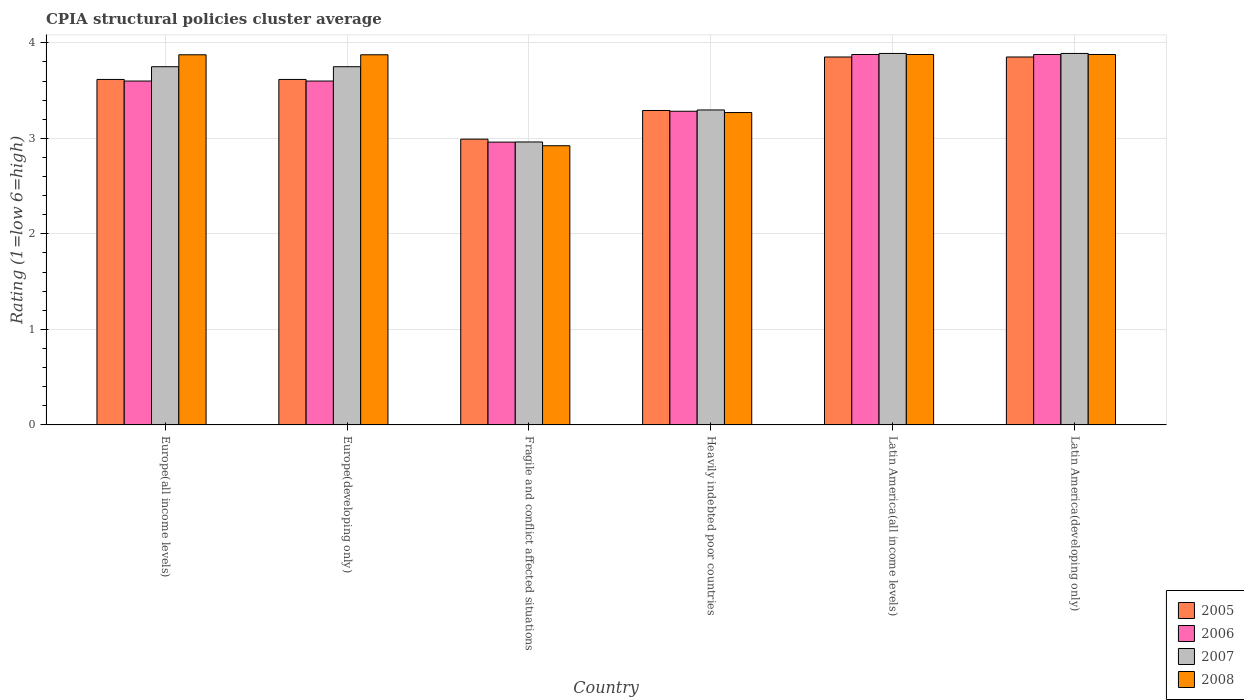Are the number of bars per tick equal to the number of legend labels?
Your answer should be compact. Yes. How many bars are there on the 1st tick from the left?
Your response must be concise. 4. How many bars are there on the 3rd tick from the right?
Offer a very short reply. 4. What is the label of the 3rd group of bars from the left?
Offer a terse response. Fragile and conflict affected situations. What is the CPIA rating in 2006 in Heavily indebted poor countries?
Provide a succinct answer. 3.28. Across all countries, what is the maximum CPIA rating in 2008?
Make the answer very short. 3.88. Across all countries, what is the minimum CPIA rating in 2006?
Ensure brevity in your answer.  2.96. In which country was the CPIA rating in 2007 maximum?
Offer a terse response. Latin America(all income levels). In which country was the CPIA rating in 2005 minimum?
Your answer should be compact. Fragile and conflict affected situations. What is the total CPIA rating in 2006 in the graph?
Keep it short and to the point. 21.2. What is the difference between the CPIA rating in 2006 in Heavily indebted poor countries and that in Latin America(developing only)?
Your response must be concise. -0.59. What is the difference between the CPIA rating in 2005 in Heavily indebted poor countries and the CPIA rating in 2008 in Latin America(all income levels)?
Keep it short and to the point. -0.59. What is the average CPIA rating in 2007 per country?
Your answer should be very brief. 3.59. What is the difference between the CPIA rating of/in 2005 and CPIA rating of/in 2007 in Latin America(all income levels)?
Your answer should be very brief. -0.04. In how many countries, is the CPIA rating in 2008 greater than 3.2?
Your response must be concise. 5. What is the ratio of the CPIA rating in 2006 in Europe(developing only) to that in Latin America(all income levels)?
Provide a short and direct response. 0.93. Is the difference between the CPIA rating in 2005 in Europe(all income levels) and Latin America(developing only) greater than the difference between the CPIA rating in 2007 in Europe(all income levels) and Latin America(developing only)?
Provide a short and direct response. No. What is the difference between the highest and the second highest CPIA rating in 2006?
Your response must be concise. -0.28. What is the difference between the highest and the lowest CPIA rating in 2008?
Your response must be concise. 0.96. Is it the case that in every country, the sum of the CPIA rating in 2008 and CPIA rating in 2006 is greater than the sum of CPIA rating in 2007 and CPIA rating in 2005?
Keep it short and to the point. No. Are the values on the major ticks of Y-axis written in scientific E-notation?
Provide a succinct answer. No. Does the graph contain any zero values?
Your answer should be compact. No. How many legend labels are there?
Your response must be concise. 4. What is the title of the graph?
Ensure brevity in your answer.  CPIA structural policies cluster average. Does "1976" appear as one of the legend labels in the graph?
Make the answer very short. No. What is the label or title of the X-axis?
Offer a very short reply. Country. What is the Rating (1=low 6=high) in 2005 in Europe(all income levels)?
Provide a short and direct response. 3.62. What is the Rating (1=low 6=high) of 2007 in Europe(all income levels)?
Provide a succinct answer. 3.75. What is the Rating (1=low 6=high) of 2008 in Europe(all income levels)?
Keep it short and to the point. 3.88. What is the Rating (1=low 6=high) in 2005 in Europe(developing only)?
Provide a succinct answer. 3.62. What is the Rating (1=low 6=high) in 2006 in Europe(developing only)?
Provide a short and direct response. 3.6. What is the Rating (1=low 6=high) of 2007 in Europe(developing only)?
Offer a very short reply. 3.75. What is the Rating (1=low 6=high) of 2008 in Europe(developing only)?
Offer a very short reply. 3.88. What is the Rating (1=low 6=high) of 2005 in Fragile and conflict affected situations?
Offer a very short reply. 2.99. What is the Rating (1=low 6=high) of 2006 in Fragile and conflict affected situations?
Make the answer very short. 2.96. What is the Rating (1=low 6=high) in 2007 in Fragile and conflict affected situations?
Keep it short and to the point. 2.96. What is the Rating (1=low 6=high) of 2008 in Fragile and conflict affected situations?
Make the answer very short. 2.92. What is the Rating (1=low 6=high) of 2005 in Heavily indebted poor countries?
Your response must be concise. 3.29. What is the Rating (1=low 6=high) of 2006 in Heavily indebted poor countries?
Your answer should be compact. 3.28. What is the Rating (1=low 6=high) in 2007 in Heavily indebted poor countries?
Offer a very short reply. 3.3. What is the Rating (1=low 6=high) of 2008 in Heavily indebted poor countries?
Your answer should be very brief. 3.27. What is the Rating (1=low 6=high) of 2005 in Latin America(all income levels)?
Your answer should be compact. 3.85. What is the Rating (1=low 6=high) in 2006 in Latin America(all income levels)?
Ensure brevity in your answer.  3.88. What is the Rating (1=low 6=high) of 2007 in Latin America(all income levels)?
Your response must be concise. 3.89. What is the Rating (1=low 6=high) of 2008 in Latin America(all income levels)?
Offer a terse response. 3.88. What is the Rating (1=low 6=high) of 2005 in Latin America(developing only)?
Offer a very short reply. 3.85. What is the Rating (1=low 6=high) of 2006 in Latin America(developing only)?
Your response must be concise. 3.88. What is the Rating (1=low 6=high) in 2007 in Latin America(developing only)?
Your answer should be compact. 3.89. What is the Rating (1=low 6=high) in 2008 in Latin America(developing only)?
Offer a very short reply. 3.88. Across all countries, what is the maximum Rating (1=low 6=high) of 2005?
Your response must be concise. 3.85. Across all countries, what is the maximum Rating (1=low 6=high) in 2006?
Keep it short and to the point. 3.88. Across all countries, what is the maximum Rating (1=low 6=high) in 2007?
Your answer should be compact. 3.89. Across all countries, what is the maximum Rating (1=low 6=high) in 2008?
Provide a short and direct response. 3.88. Across all countries, what is the minimum Rating (1=low 6=high) in 2005?
Make the answer very short. 2.99. Across all countries, what is the minimum Rating (1=low 6=high) of 2006?
Provide a short and direct response. 2.96. Across all countries, what is the minimum Rating (1=low 6=high) of 2007?
Provide a succinct answer. 2.96. Across all countries, what is the minimum Rating (1=low 6=high) in 2008?
Offer a terse response. 2.92. What is the total Rating (1=low 6=high) in 2005 in the graph?
Your response must be concise. 21.22. What is the total Rating (1=low 6=high) of 2006 in the graph?
Give a very brief answer. 21.2. What is the total Rating (1=low 6=high) of 2007 in the graph?
Your response must be concise. 21.54. What is the total Rating (1=low 6=high) of 2008 in the graph?
Provide a succinct answer. 21.7. What is the difference between the Rating (1=low 6=high) in 2006 in Europe(all income levels) and that in Europe(developing only)?
Ensure brevity in your answer.  0. What is the difference between the Rating (1=low 6=high) in 2007 in Europe(all income levels) and that in Europe(developing only)?
Give a very brief answer. 0. What is the difference between the Rating (1=low 6=high) of 2005 in Europe(all income levels) and that in Fragile and conflict affected situations?
Your answer should be compact. 0.62. What is the difference between the Rating (1=low 6=high) of 2006 in Europe(all income levels) and that in Fragile and conflict affected situations?
Provide a succinct answer. 0.64. What is the difference between the Rating (1=low 6=high) of 2007 in Europe(all income levels) and that in Fragile and conflict affected situations?
Provide a succinct answer. 0.79. What is the difference between the Rating (1=low 6=high) of 2008 in Europe(all income levels) and that in Fragile and conflict affected situations?
Offer a terse response. 0.95. What is the difference between the Rating (1=low 6=high) of 2005 in Europe(all income levels) and that in Heavily indebted poor countries?
Your answer should be compact. 0.33. What is the difference between the Rating (1=low 6=high) in 2006 in Europe(all income levels) and that in Heavily indebted poor countries?
Ensure brevity in your answer.  0.32. What is the difference between the Rating (1=low 6=high) in 2007 in Europe(all income levels) and that in Heavily indebted poor countries?
Make the answer very short. 0.45. What is the difference between the Rating (1=low 6=high) in 2008 in Europe(all income levels) and that in Heavily indebted poor countries?
Offer a very short reply. 0.6. What is the difference between the Rating (1=low 6=high) of 2005 in Europe(all income levels) and that in Latin America(all income levels)?
Provide a succinct answer. -0.24. What is the difference between the Rating (1=low 6=high) in 2006 in Europe(all income levels) and that in Latin America(all income levels)?
Ensure brevity in your answer.  -0.28. What is the difference between the Rating (1=low 6=high) in 2007 in Europe(all income levels) and that in Latin America(all income levels)?
Offer a very short reply. -0.14. What is the difference between the Rating (1=low 6=high) in 2008 in Europe(all income levels) and that in Latin America(all income levels)?
Provide a short and direct response. -0. What is the difference between the Rating (1=low 6=high) of 2005 in Europe(all income levels) and that in Latin America(developing only)?
Offer a terse response. -0.24. What is the difference between the Rating (1=low 6=high) in 2006 in Europe(all income levels) and that in Latin America(developing only)?
Your response must be concise. -0.28. What is the difference between the Rating (1=low 6=high) in 2007 in Europe(all income levels) and that in Latin America(developing only)?
Give a very brief answer. -0.14. What is the difference between the Rating (1=low 6=high) of 2008 in Europe(all income levels) and that in Latin America(developing only)?
Offer a very short reply. -0. What is the difference between the Rating (1=low 6=high) in 2005 in Europe(developing only) and that in Fragile and conflict affected situations?
Offer a terse response. 0.62. What is the difference between the Rating (1=low 6=high) of 2006 in Europe(developing only) and that in Fragile and conflict affected situations?
Provide a short and direct response. 0.64. What is the difference between the Rating (1=low 6=high) in 2007 in Europe(developing only) and that in Fragile and conflict affected situations?
Provide a short and direct response. 0.79. What is the difference between the Rating (1=low 6=high) in 2008 in Europe(developing only) and that in Fragile and conflict affected situations?
Your answer should be compact. 0.95. What is the difference between the Rating (1=low 6=high) of 2005 in Europe(developing only) and that in Heavily indebted poor countries?
Ensure brevity in your answer.  0.33. What is the difference between the Rating (1=low 6=high) of 2006 in Europe(developing only) and that in Heavily indebted poor countries?
Provide a short and direct response. 0.32. What is the difference between the Rating (1=low 6=high) in 2007 in Europe(developing only) and that in Heavily indebted poor countries?
Make the answer very short. 0.45. What is the difference between the Rating (1=low 6=high) in 2008 in Europe(developing only) and that in Heavily indebted poor countries?
Give a very brief answer. 0.6. What is the difference between the Rating (1=low 6=high) of 2005 in Europe(developing only) and that in Latin America(all income levels)?
Offer a terse response. -0.24. What is the difference between the Rating (1=low 6=high) of 2006 in Europe(developing only) and that in Latin America(all income levels)?
Give a very brief answer. -0.28. What is the difference between the Rating (1=low 6=high) in 2007 in Europe(developing only) and that in Latin America(all income levels)?
Provide a succinct answer. -0.14. What is the difference between the Rating (1=low 6=high) in 2008 in Europe(developing only) and that in Latin America(all income levels)?
Give a very brief answer. -0. What is the difference between the Rating (1=low 6=high) of 2005 in Europe(developing only) and that in Latin America(developing only)?
Provide a short and direct response. -0.24. What is the difference between the Rating (1=low 6=high) of 2006 in Europe(developing only) and that in Latin America(developing only)?
Provide a succinct answer. -0.28. What is the difference between the Rating (1=low 6=high) of 2007 in Europe(developing only) and that in Latin America(developing only)?
Give a very brief answer. -0.14. What is the difference between the Rating (1=low 6=high) of 2008 in Europe(developing only) and that in Latin America(developing only)?
Provide a short and direct response. -0. What is the difference between the Rating (1=low 6=high) in 2006 in Fragile and conflict affected situations and that in Heavily indebted poor countries?
Provide a short and direct response. -0.32. What is the difference between the Rating (1=low 6=high) of 2007 in Fragile and conflict affected situations and that in Heavily indebted poor countries?
Ensure brevity in your answer.  -0.34. What is the difference between the Rating (1=low 6=high) in 2008 in Fragile and conflict affected situations and that in Heavily indebted poor countries?
Offer a very short reply. -0.35. What is the difference between the Rating (1=low 6=high) in 2005 in Fragile and conflict affected situations and that in Latin America(all income levels)?
Your response must be concise. -0.86. What is the difference between the Rating (1=low 6=high) in 2006 in Fragile and conflict affected situations and that in Latin America(all income levels)?
Keep it short and to the point. -0.92. What is the difference between the Rating (1=low 6=high) in 2007 in Fragile and conflict affected situations and that in Latin America(all income levels)?
Your response must be concise. -0.93. What is the difference between the Rating (1=low 6=high) of 2008 in Fragile and conflict affected situations and that in Latin America(all income levels)?
Your answer should be very brief. -0.96. What is the difference between the Rating (1=low 6=high) in 2005 in Fragile and conflict affected situations and that in Latin America(developing only)?
Your answer should be compact. -0.86. What is the difference between the Rating (1=low 6=high) of 2006 in Fragile and conflict affected situations and that in Latin America(developing only)?
Provide a short and direct response. -0.92. What is the difference between the Rating (1=low 6=high) of 2007 in Fragile and conflict affected situations and that in Latin America(developing only)?
Provide a short and direct response. -0.93. What is the difference between the Rating (1=low 6=high) of 2008 in Fragile and conflict affected situations and that in Latin America(developing only)?
Provide a short and direct response. -0.96. What is the difference between the Rating (1=low 6=high) of 2005 in Heavily indebted poor countries and that in Latin America(all income levels)?
Offer a very short reply. -0.56. What is the difference between the Rating (1=low 6=high) of 2006 in Heavily indebted poor countries and that in Latin America(all income levels)?
Make the answer very short. -0.59. What is the difference between the Rating (1=low 6=high) of 2007 in Heavily indebted poor countries and that in Latin America(all income levels)?
Make the answer very short. -0.59. What is the difference between the Rating (1=low 6=high) of 2008 in Heavily indebted poor countries and that in Latin America(all income levels)?
Your answer should be very brief. -0.61. What is the difference between the Rating (1=low 6=high) in 2005 in Heavily indebted poor countries and that in Latin America(developing only)?
Give a very brief answer. -0.56. What is the difference between the Rating (1=low 6=high) in 2006 in Heavily indebted poor countries and that in Latin America(developing only)?
Give a very brief answer. -0.59. What is the difference between the Rating (1=low 6=high) of 2007 in Heavily indebted poor countries and that in Latin America(developing only)?
Ensure brevity in your answer.  -0.59. What is the difference between the Rating (1=low 6=high) of 2008 in Heavily indebted poor countries and that in Latin America(developing only)?
Your answer should be compact. -0.61. What is the difference between the Rating (1=low 6=high) in 2005 in Latin America(all income levels) and that in Latin America(developing only)?
Your answer should be very brief. 0. What is the difference between the Rating (1=low 6=high) of 2007 in Latin America(all income levels) and that in Latin America(developing only)?
Your answer should be very brief. 0. What is the difference between the Rating (1=low 6=high) of 2008 in Latin America(all income levels) and that in Latin America(developing only)?
Your answer should be very brief. 0. What is the difference between the Rating (1=low 6=high) in 2005 in Europe(all income levels) and the Rating (1=low 6=high) in 2006 in Europe(developing only)?
Provide a succinct answer. 0.02. What is the difference between the Rating (1=low 6=high) of 2005 in Europe(all income levels) and the Rating (1=low 6=high) of 2007 in Europe(developing only)?
Your answer should be compact. -0.13. What is the difference between the Rating (1=low 6=high) in 2005 in Europe(all income levels) and the Rating (1=low 6=high) in 2008 in Europe(developing only)?
Keep it short and to the point. -0.26. What is the difference between the Rating (1=low 6=high) in 2006 in Europe(all income levels) and the Rating (1=low 6=high) in 2008 in Europe(developing only)?
Your answer should be very brief. -0.28. What is the difference between the Rating (1=low 6=high) of 2007 in Europe(all income levels) and the Rating (1=low 6=high) of 2008 in Europe(developing only)?
Give a very brief answer. -0.12. What is the difference between the Rating (1=low 6=high) in 2005 in Europe(all income levels) and the Rating (1=low 6=high) in 2006 in Fragile and conflict affected situations?
Provide a short and direct response. 0.66. What is the difference between the Rating (1=low 6=high) of 2005 in Europe(all income levels) and the Rating (1=low 6=high) of 2007 in Fragile and conflict affected situations?
Your answer should be compact. 0.65. What is the difference between the Rating (1=low 6=high) in 2005 in Europe(all income levels) and the Rating (1=low 6=high) in 2008 in Fragile and conflict affected situations?
Your answer should be compact. 0.69. What is the difference between the Rating (1=low 6=high) in 2006 in Europe(all income levels) and the Rating (1=low 6=high) in 2007 in Fragile and conflict affected situations?
Provide a succinct answer. 0.64. What is the difference between the Rating (1=low 6=high) in 2006 in Europe(all income levels) and the Rating (1=low 6=high) in 2008 in Fragile and conflict affected situations?
Offer a very short reply. 0.68. What is the difference between the Rating (1=low 6=high) of 2007 in Europe(all income levels) and the Rating (1=low 6=high) of 2008 in Fragile and conflict affected situations?
Your answer should be very brief. 0.83. What is the difference between the Rating (1=low 6=high) of 2005 in Europe(all income levels) and the Rating (1=low 6=high) of 2006 in Heavily indebted poor countries?
Your answer should be compact. 0.33. What is the difference between the Rating (1=low 6=high) in 2005 in Europe(all income levels) and the Rating (1=low 6=high) in 2007 in Heavily indebted poor countries?
Make the answer very short. 0.32. What is the difference between the Rating (1=low 6=high) in 2005 in Europe(all income levels) and the Rating (1=low 6=high) in 2008 in Heavily indebted poor countries?
Offer a very short reply. 0.35. What is the difference between the Rating (1=low 6=high) in 2006 in Europe(all income levels) and the Rating (1=low 6=high) in 2007 in Heavily indebted poor countries?
Your answer should be very brief. 0.3. What is the difference between the Rating (1=low 6=high) of 2006 in Europe(all income levels) and the Rating (1=low 6=high) of 2008 in Heavily indebted poor countries?
Your answer should be very brief. 0.33. What is the difference between the Rating (1=low 6=high) of 2007 in Europe(all income levels) and the Rating (1=low 6=high) of 2008 in Heavily indebted poor countries?
Provide a succinct answer. 0.48. What is the difference between the Rating (1=low 6=high) of 2005 in Europe(all income levels) and the Rating (1=low 6=high) of 2006 in Latin America(all income levels)?
Your answer should be compact. -0.26. What is the difference between the Rating (1=low 6=high) of 2005 in Europe(all income levels) and the Rating (1=low 6=high) of 2007 in Latin America(all income levels)?
Offer a terse response. -0.27. What is the difference between the Rating (1=low 6=high) of 2005 in Europe(all income levels) and the Rating (1=low 6=high) of 2008 in Latin America(all income levels)?
Your answer should be compact. -0.26. What is the difference between the Rating (1=low 6=high) of 2006 in Europe(all income levels) and the Rating (1=low 6=high) of 2007 in Latin America(all income levels)?
Keep it short and to the point. -0.29. What is the difference between the Rating (1=low 6=high) of 2006 in Europe(all income levels) and the Rating (1=low 6=high) of 2008 in Latin America(all income levels)?
Provide a succinct answer. -0.28. What is the difference between the Rating (1=low 6=high) in 2007 in Europe(all income levels) and the Rating (1=low 6=high) in 2008 in Latin America(all income levels)?
Your answer should be compact. -0.13. What is the difference between the Rating (1=low 6=high) in 2005 in Europe(all income levels) and the Rating (1=low 6=high) in 2006 in Latin America(developing only)?
Your answer should be compact. -0.26. What is the difference between the Rating (1=low 6=high) of 2005 in Europe(all income levels) and the Rating (1=low 6=high) of 2007 in Latin America(developing only)?
Give a very brief answer. -0.27. What is the difference between the Rating (1=low 6=high) of 2005 in Europe(all income levels) and the Rating (1=low 6=high) of 2008 in Latin America(developing only)?
Your answer should be very brief. -0.26. What is the difference between the Rating (1=low 6=high) in 2006 in Europe(all income levels) and the Rating (1=low 6=high) in 2007 in Latin America(developing only)?
Your response must be concise. -0.29. What is the difference between the Rating (1=low 6=high) of 2006 in Europe(all income levels) and the Rating (1=low 6=high) of 2008 in Latin America(developing only)?
Make the answer very short. -0.28. What is the difference between the Rating (1=low 6=high) of 2007 in Europe(all income levels) and the Rating (1=low 6=high) of 2008 in Latin America(developing only)?
Ensure brevity in your answer.  -0.13. What is the difference between the Rating (1=low 6=high) of 2005 in Europe(developing only) and the Rating (1=low 6=high) of 2006 in Fragile and conflict affected situations?
Make the answer very short. 0.66. What is the difference between the Rating (1=low 6=high) in 2005 in Europe(developing only) and the Rating (1=low 6=high) in 2007 in Fragile and conflict affected situations?
Give a very brief answer. 0.65. What is the difference between the Rating (1=low 6=high) in 2005 in Europe(developing only) and the Rating (1=low 6=high) in 2008 in Fragile and conflict affected situations?
Offer a terse response. 0.69. What is the difference between the Rating (1=low 6=high) in 2006 in Europe(developing only) and the Rating (1=low 6=high) in 2007 in Fragile and conflict affected situations?
Make the answer very short. 0.64. What is the difference between the Rating (1=low 6=high) in 2006 in Europe(developing only) and the Rating (1=low 6=high) in 2008 in Fragile and conflict affected situations?
Ensure brevity in your answer.  0.68. What is the difference between the Rating (1=low 6=high) of 2007 in Europe(developing only) and the Rating (1=low 6=high) of 2008 in Fragile and conflict affected situations?
Ensure brevity in your answer.  0.83. What is the difference between the Rating (1=low 6=high) in 2005 in Europe(developing only) and the Rating (1=low 6=high) in 2006 in Heavily indebted poor countries?
Provide a succinct answer. 0.33. What is the difference between the Rating (1=low 6=high) in 2005 in Europe(developing only) and the Rating (1=low 6=high) in 2007 in Heavily indebted poor countries?
Provide a succinct answer. 0.32. What is the difference between the Rating (1=low 6=high) in 2005 in Europe(developing only) and the Rating (1=low 6=high) in 2008 in Heavily indebted poor countries?
Ensure brevity in your answer.  0.35. What is the difference between the Rating (1=low 6=high) of 2006 in Europe(developing only) and the Rating (1=low 6=high) of 2007 in Heavily indebted poor countries?
Offer a terse response. 0.3. What is the difference between the Rating (1=low 6=high) in 2006 in Europe(developing only) and the Rating (1=low 6=high) in 2008 in Heavily indebted poor countries?
Offer a very short reply. 0.33. What is the difference between the Rating (1=low 6=high) of 2007 in Europe(developing only) and the Rating (1=low 6=high) of 2008 in Heavily indebted poor countries?
Your response must be concise. 0.48. What is the difference between the Rating (1=low 6=high) in 2005 in Europe(developing only) and the Rating (1=low 6=high) in 2006 in Latin America(all income levels)?
Keep it short and to the point. -0.26. What is the difference between the Rating (1=low 6=high) in 2005 in Europe(developing only) and the Rating (1=low 6=high) in 2007 in Latin America(all income levels)?
Your answer should be compact. -0.27. What is the difference between the Rating (1=low 6=high) of 2005 in Europe(developing only) and the Rating (1=low 6=high) of 2008 in Latin America(all income levels)?
Make the answer very short. -0.26. What is the difference between the Rating (1=low 6=high) in 2006 in Europe(developing only) and the Rating (1=low 6=high) in 2007 in Latin America(all income levels)?
Your answer should be compact. -0.29. What is the difference between the Rating (1=low 6=high) in 2006 in Europe(developing only) and the Rating (1=low 6=high) in 2008 in Latin America(all income levels)?
Offer a very short reply. -0.28. What is the difference between the Rating (1=low 6=high) of 2007 in Europe(developing only) and the Rating (1=low 6=high) of 2008 in Latin America(all income levels)?
Provide a succinct answer. -0.13. What is the difference between the Rating (1=low 6=high) of 2005 in Europe(developing only) and the Rating (1=low 6=high) of 2006 in Latin America(developing only)?
Your response must be concise. -0.26. What is the difference between the Rating (1=low 6=high) of 2005 in Europe(developing only) and the Rating (1=low 6=high) of 2007 in Latin America(developing only)?
Provide a succinct answer. -0.27. What is the difference between the Rating (1=low 6=high) in 2005 in Europe(developing only) and the Rating (1=low 6=high) in 2008 in Latin America(developing only)?
Your answer should be very brief. -0.26. What is the difference between the Rating (1=low 6=high) in 2006 in Europe(developing only) and the Rating (1=low 6=high) in 2007 in Latin America(developing only)?
Give a very brief answer. -0.29. What is the difference between the Rating (1=low 6=high) in 2006 in Europe(developing only) and the Rating (1=low 6=high) in 2008 in Latin America(developing only)?
Provide a short and direct response. -0.28. What is the difference between the Rating (1=low 6=high) of 2007 in Europe(developing only) and the Rating (1=low 6=high) of 2008 in Latin America(developing only)?
Give a very brief answer. -0.13. What is the difference between the Rating (1=low 6=high) of 2005 in Fragile and conflict affected situations and the Rating (1=low 6=high) of 2006 in Heavily indebted poor countries?
Give a very brief answer. -0.29. What is the difference between the Rating (1=low 6=high) in 2005 in Fragile and conflict affected situations and the Rating (1=low 6=high) in 2007 in Heavily indebted poor countries?
Ensure brevity in your answer.  -0.31. What is the difference between the Rating (1=low 6=high) of 2005 in Fragile and conflict affected situations and the Rating (1=low 6=high) of 2008 in Heavily indebted poor countries?
Keep it short and to the point. -0.28. What is the difference between the Rating (1=low 6=high) in 2006 in Fragile and conflict affected situations and the Rating (1=low 6=high) in 2007 in Heavily indebted poor countries?
Offer a very short reply. -0.34. What is the difference between the Rating (1=low 6=high) in 2006 in Fragile and conflict affected situations and the Rating (1=low 6=high) in 2008 in Heavily indebted poor countries?
Your answer should be very brief. -0.31. What is the difference between the Rating (1=low 6=high) in 2007 in Fragile and conflict affected situations and the Rating (1=low 6=high) in 2008 in Heavily indebted poor countries?
Provide a succinct answer. -0.31. What is the difference between the Rating (1=low 6=high) of 2005 in Fragile and conflict affected situations and the Rating (1=low 6=high) of 2006 in Latin America(all income levels)?
Your answer should be compact. -0.89. What is the difference between the Rating (1=low 6=high) in 2005 in Fragile and conflict affected situations and the Rating (1=low 6=high) in 2007 in Latin America(all income levels)?
Your response must be concise. -0.9. What is the difference between the Rating (1=low 6=high) of 2005 in Fragile and conflict affected situations and the Rating (1=low 6=high) of 2008 in Latin America(all income levels)?
Provide a succinct answer. -0.89. What is the difference between the Rating (1=low 6=high) of 2006 in Fragile and conflict affected situations and the Rating (1=low 6=high) of 2007 in Latin America(all income levels)?
Provide a short and direct response. -0.93. What is the difference between the Rating (1=low 6=high) of 2006 in Fragile and conflict affected situations and the Rating (1=low 6=high) of 2008 in Latin America(all income levels)?
Keep it short and to the point. -0.92. What is the difference between the Rating (1=low 6=high) of 2007 in Fragile and conflict affected situations and the Rating (1=low 6=high) of 2008 in Latin America(all income levels)?
Keep it short and to the point. -0.92. What is the difference between the Rating (1=low 6=high) of 2005 in Fragile and conflict affected situations and the Rating (1=low 6=high) of 2006 in Latin America(developing only)?
Your response must be concise. -0.89. What is the difference between the Rating (1=low 6=high) in 2005 in Fragile and conflict affected situations and the Rating (1=low 6=high) in 2007 in Latin America(developing only)?
Provide a succinct answer. -0.9. What is the difference between the Rating (1=low 6=high) of 2005 in Fragile and conflict affected situations and the Rating (1=low 6=high) of 2008 in Latin America(developing only)?
Offer a terse response. -0.89. What is the difference between the Rating (1=low 6=high) of 2006 in Fragile and conflict affected situations and the Rating (1=low 6=high) of 2007 in Latin America(developing only)?
Your response must be concise. -0.93. What is the difference between the Rating (1=low 6=high) in 2006 in Fragile and conflict affected situations and the Rating (1=low 6=high) in 2008 in Latin America(developing only)?
Keep it short and to the point. -0.92. What is the difference between the Rating (1=low 6=high) in 2007 in Fragile and conflict affected situations and the Rating (1=low 6=high) in 2008 in Latin America(developing only)?
Provide a short and direct response. -0.92. What is the difference between the Rating (1=low 6=high) in 2005 in Heavily indebted poor countries and the Rating (1=low 6=high) in 2006 in Latin America(all income levels)?
Give a very brief answer. -0.59. What is the difference between the Rating (1=low 6=high) in 2005 in Heavily indebted poor countries and the Rating (1=low 6=high) in 2007 in Latin America(all income levels)?
Your answer should be compact. -0.6. What is the difference between the Rating (1=low 6=high) in 2005 in Heavily indebted poor countries and the Rating (1=low 6=high) in 2008 in Latin America(all income levels)?
Make the answer very short. -0.59. What is the difference between the Rating (1=low 6=high) in 2006 in Heavily indebted poor countries and the Rating (1=low 6=high) in 2007 in Latin America(all income levels)?
Give a very brief answer. -0.61. What is the difference between the Rating (1=low 6=high) in 2006 in Heavily indebted poor countries and the Rating (1=low 6=high) in 2008 in Latin America(all income levels)?
Your answer should be compact. -0.59. What is the difference between the Rating (1=low 6=high) in 2007 in Heavily indebted poor countries and the Rating (1=low 6=high) in 2008 in Latin America(all income levels)?
Your answer should be compact. -0.58. What is the difference between the Rating (1=low 6=high) in 2005 in Heavily indebted poor countries and the Rating (1=low 6=high) in 2006 in Latin America(developing only)?
Your answer should be compact. -0.59. What is the difference between the Rating (1=low 6=high) of 2005 in Heavily indebted poor countries and the Rating (1=low 6=high) of 2007 in Latin America(developing only)?
Your response must be concise. -0.6. What is the difference between the Rating (1=low 6=high) of 2005 in Heavily indebted poor countries and the Rating (1=low 6=high) of 2008 in Latin America(developing only)?
Keep it short and to the point. -0.59. What is the difference between the Rating (1=low 6=high) in 2006 in Heavily indebted poor countries and the Rating (1=low 6=high) in 2007 in Latin America(developing only)?
Your answer should be compact. -0.61. What is the difference between the Rating (1=low 6=high) in 2006 in Heavily indebted poor countries and the Rating (1=low 6=high) in 2008 in Latin America(developing only)?
Your answer should be compact. -0.59. What is the difference between the Rating (1=low 6=high) of 2007 in Heavily indebted poor countries and the Rating (1=low 6=high) of 2008 in Latin America(developing only)?
Offer a very short reply. -0.58. What is the difference between the Rating (1=low 6=high) in 2005 in Latin America(all income levels) and the Rating (1=low 6=high) in 2006 in Latin America(developing only)?
Keep it short and to the point. -0.03. What is the difference between the Rating (1=low 6=high) in 2005 in Latin America(all income levels) and the Rating (1=low 6=high) in 2007 in Latin America(developing only)?
Your response must be concise. -0.04. What is the difference between the Rating (1=low 6=high) of 2005 in Latin America(all income levels) and the Rating (1=low 6=high) of 2008 in Latin America(developing only)?
Provide a succinct answer. -0.03. What is the difference between the Rating (1=low 6=high) of 2006 in Latin America(all income levels) and the Rating (1=low 6=high) of 2007 in Latin America(developing only)?
Offer a terse response. -0.01. What is the difference between the Rating (1=low 6=high) in 2006 in Latin America(all income levels) and the Rating (1=low 6=high) in 2008 in Latin America(developing only)?
Keep it short and to the point. 0. What is the difference between the Rating (1=low 6=high) of 2007 in Latin America(all income levels) and the Rating (1=low 6=high) of 2008 in Latin America(developing only)?
Your response must be concise. 0.01. What is the average Rating (1=low 6=high) of 2005 per country?
Offer a very short reply. 3.54. What is the average Rating (1=low 6=high) of 2006 per country?
Your answer should be compact. 3.53. What is the average Rating (1=low 6=high) of 2007 per country?
Make the answer very short. 3.59. What is the average Rating (1=low 6=high) in 2008 per country?
Ensure brevity in your answer.  3.62. What is the difference between the Rating (1=low 6=high) in 2005 and Rating (1=low 6=high) in 2006 in Europe(all income levels)?
Offer a terse response. 0.02. What is the difference between the Rating (1=low 6=high) of 2005 and Rating (1=low 6=high) of 2007 in Europe(all income levels)?
Offer a very short reply. -0.13. What is the difference between the Rating (1=low 6=high) of 2005 and Rating (1=low 6=high) of 2008 in Europe(all income levels)?
Ensure brevity in your answer.  -0.26. What is the difference between the Rating (1=low 6=high) in 2006 and Rating (1=low 6=high) in 2008 in Europe(all income levels)?
Make the answer very short. -0.28. What is the difference between the Rating (1=low 6=high) of 2007 and Rating (1=low 6=high) of 2008 in Europe(all income levels)?
Your answer should be compact. -0.12. What is the difference between the Rating (1=low 6=high) in 2005 and Rating (1=low 6=high) in 2006 in Europe(developing only)?
Give a very brief answer. 0.02. What is the difference between the Rating (1=low 6=high) of 2005 and Rating (1=low 6=high) of 2007 in Europe(developing only)?
Offer a very short reply. -0.13. What is the difference between the Rating (1=low 6=high) in 2005 and Rating (1=low 6=high) in 2008 in Europe(developing only)?
Provide a succinct answer. -0.26. What is the difference between the Rating (1=low 6=high) of 2006 and Rating (1=low 6=high) of 2008 in Europe(developing only)?
Offer a very short reply. -0.28. What is the difference between the Rating (1=low 6=high) in 2007 and Rating (1=low 6=high) in 2008 in Europe(developing only)?
Offer a very short reply. -0.12. What is the difference between the Rating (1=low 6=high) of 2005 and Rating (1=low 6=high) of 2006 in Fragile and conflict affected situations?
Make the answer very short. 0.03. What is the difference between the Rating (1=low 6=high) of 2005 and Rating (1=low 6=high) of 2007 in Fragile and conflict affected situations?
Provide a succinct answer. 0.03. What is the difference between the Rating (1=low 6=high) of 2005 and Rating (1=low 6=high) of 2008 in Fragile and conflict affected situations?
Keep it short and to the point. 0.07. What is the difference between the Rating (1=low 6=high) in 2006 and Rating (1=low 6=high) in 2007 in Fragile and conflict affected situations?
Your answer should be very brief. -0. What is the difference between the Rating (1=low 6=high) of 2006 and Rating (1=low 6=high) of 2008 in Fragile and conflict affected situations?
Your response must be concise. 0.04. What is the difference between the Rating (1=low 6=high) in 2007 and Rating (1=low 6=high) in 2008 in Fragile and conflict affected situations?
Offer a very short reply. 0.04. What is the difference between the Rating (1=low 6=high) of 2005 and Rating (1=low 6=high) of 2006 in Heavily indebted poor countries?
Provide a succinct answer. 0.01. What is the difference between the Rating (1=low 6=high) of 2005 and Rating (1=low 6=high) of 2007 in Heavily indebted poor countries?
Your response must be concise. -0.01. What is the difference between the Rating (1=low 6=high) in 2005 and Rating (1=low 6=high) in 2008 in Heavily indebted poor countries?
Offer a terse response. 0.02. What is the difference between the Rating (1=low 6=high) of 2006 and Rating (1=low 6=high) of 2007 in Heavily indebted poor countries?
Keep it short and to the point. -0.01. What is the difference between the Rating (1=low 6=high) in 2006 and Rating (1=low 6=high) in 2008 in Heavily indebted poor countries?
Your answer should be very brief. 0.01. What is the difference between the Rating (1=low 6=high) in 2007 and Rating (1=low 6=high) in 2008 in Heavily indebted poor countries?
Make the answer very short. 0.03. What is the difference between the Rating (1=low 6=high) of 2005 and Rating (1=low 6=high) of 2006 in Latin America(all income levels)?
Ensure brevity in your answer.  -0.03. What is the difference between the Rating (1=low 6=high) of 2005 and Rating (1=low 6=high) of 2007 in Latin America(all income levels)?
Provide a succinct answer. -0.04. What is the difference between the Rating (1=low 6=high) of 2005 and Rating (1=low 6=high) of 2008 in Latin America(all income levels)?
Offer a very short reply. -0.03. What is the difference between the Rating (1=low 6=high) in 2006 and Rating (1=low 6=high) in 2007 in Latin America(all income levels)?
Make the answer very short. -0.01. What is the difference between the Rating (1=low 6=high) in 2006 and Rating (1=low 6=high) in 2008 in Latin America(all income levels)?
Your response must be concise. 0. What is the difference between the Rating (1=low 6=high) in 2007 and Rating (1=low 6=high) in 2008 in Latin America(all income levels)?
Your answer should be very brief. 0.01. What is the difference between the Rating (1=low 6=high) of 2005 and Rating (1=low 6=high) of 2006 in Latin America(developing only)?
Offer a terse response. -0.03. What is the difference between the Rating (1=low 6=high) of 2005 and Rating (1=low 6=high) of 2007 in Latin America(developing only)?
Your answer should be compact. -0.04. What is the difference between the Rating (1=low 6=high) in 2005 and Rating (1=low 6=high) in 2008 in Latin America(developing only)?
Make the answer very short. -0.03. What is the difference between the Rating (1=low 6=high) of 2006 and Rating (1=low 6=high) of 2007 in Latin America(developing only)?
Ensure brevity in your answer.  -0.01. What is the difference between the Rating (1=low 6=high) of 2006 and Rating (1=low 6=high) of 2008 in Latin America(developing only)?
Give a very brief answer. 0. What is the difference between the Rating (1=low 6=high) of 2007 and Rating (1=low 6=high) of 2008 in Latin America(developing only)?
Provide a succinct answer. 0.01. What is the ratio of the Rating (1=low 6=high) of 2008 in Europe(all income levels) to that in Europe(developing only)?
Provide a succinct answer. 1. What is the ratio of the Rating (1=low 6=high) of 2005 in Europe(all income levels) to that in Fragile and conflict affected situations?
Your response must be concise. 1.21. What is the ratio of the Rating (1=low 6=high) in 2006 in Europe(all income levels) to that in Fragile and conflict affected situations?
Offer a very short reply. 1.22. What is the ratio of the Rating (1=low 6=high) of 2007 in Europe(all income levels) to that in Fragile and conflict affected situations?
Offer a terse response. 1.27. What is the ratio of the Rating (1=low 6=high) of 2008 in Europe(all income levels) to that in Fragile and conflict affected situations?
Offer a very short reply. 1.33. What is the ratio of the Rating (1=low 6=high) of 2005 in Europe(all income levels) to that in Heavily indebted poor countries?
Keep it short and to the point. 1.1. What is the ratio of the Rating (1=low 6=high) in 2006 in Europe(all income levels) to that in Heavily indebted poor countries?
Give a very brief answer. 1.1. What is the ratio of the Rating (1=low 6=high) of 2007 in Europe(all income levels) to that in Heavily indebted poor countries?
Keep it short and to the point. 1.14. What is the ratio of the Rating (1=low 6=high) in 2008 in Europe(all income levels) to that in Heavily indebted poor countries?
Give a very brief answer. 1.18. What is the ratio of the Rating (1=low 6=high) in 2005 in Europe(all income levels) to that in Latin America(all income levels)?
Offer a very short reply. 0.94. What is the ratio of the Rating (1=low 6=high) in 2006 in Europe(all income levels) to that in Latin America(all income levels)?
Make the answer very short. 0.93. What is the ratio of the Rating (1=low 6=high) of 2007 in Europe(all income levels) to that in Latin America(all income levels)?
Make the answer very short. 0.96. What is the ratio of the Rating (1=low 6=high) of 2005 in Europe(all income levels) to that in Latin America(developing only)?
Your response must be concise. 0.94. What is the ratio of the Rating (1=low 6=high) in 2006 in Europe(all income levels) to that in Latin America(developing only)?
Give a very brief answer. 0.93. What is the ratio of the Rating (1=low 6=high) of 2005 in Europe(developing only) to that in Fragile and conflict affected situations?
Make the answer very short. 1.21. What is the ratio of the Rating (1=low 6=high) in 2006 in Europe(developing only) to that in Fragile and conflict affected situations?
Give a very brief answer. 1.22. What is the ratio of the Rating (1=low 6=high) in 2007 in Europe(developing only) to that in Fragile and conflict affected situations?
Make the answer very short. 1.27. What is the ratio of the Rating (1=low 6=high) in 2008 in Europe(developing only) to that in Fragile and conflict affected situations?
Ensure brevity in your answer.  1.33. What is the ratio of the Rating (1=low 6=high) in 2005 in Europe(developing only) to that in Heavily indebted poor countries?
Ensure brevity in your answer.  1.1. What is the ratio of the Rating (1=low 6=high) of 2006 in Europe(developing only) to that in Heavily indebted poor countries?
Provide a short and direct response. 1.1. What is the ratio of the Rating (1=low 6=high) of 2007 in Europe(developing only) to that in Heavily indebted poor countries?
Your answer should be compact. 1.14. What is the ratio of the Rating (1=low 6=high) in 2008 in Europe(developing only) to that in Heavily indebted poor countries?
Make the answer very short. 1.18. What is the ratio of the Rating (1=low 6=high) in 2005 in Europe(developing only) to that in Latin America(all income levels)?
Your answer should be very brief. 0.94. What is the ratio of the Rating (1=low 6=high) in 2006 in Europe(developing only) to that in Latin America(all income levels)?
Your response must be concise. 0.93. What is the ratio of the Rating (1=low 6=high) in 2005 in Europe(developing only) to that in Latin America(developing only)?
Your answer should be compact. 0.94. What is the ratio of the Rating (1=low 6=high) of 2006 in Europe(developing only) to that in Latin America(developing only)?
Give a very brief answer. 0.93. What is the ratio of the Rating (1=low 6=high) of 2005 in Fragile and conflict affected situations to that in Heavily indebted poor countries?
Your answer should be compact. 0.91. What is the ratio of the Rating (1=low 6=high) of 2006 in Fragile and conflict affected situations to that in Heavily indebted poor countries?
Your answer should be compact. 0.9. What is the ratio of the Rating (1=low 6=high) in 2007 in Fragile and conflict affected situations to that in Heavily indebted poor countries?
Provide a short and direct response. 0.9. What is the ratio of the Rating (1=low 6=high) in 2008 in Fragile and conflict affected situations to that in Heavily indebted poor countries?
Offer a very short reply. 0.89. What is the ratio of the Rating (1=low 6=high) of 2005 in Fragile and conflict affected situations to that in Latin America(all income levels)?
Offer a terse response. 0.78. What is the ratio of the Rating (1=low 6=high) of 2006 in Fragile and conflict affected situations to that in Latin America(all income levels)?
Your response must be concise. 0.76. What is the ratio of the Rating (1=low 6=high) in 2007 in Fragile and conflict affected situations to that in Latin America(all income levels)?
Provide a succinct answer. 0.76. What is the ratio of the Rating (1=low 6=high) in 2008 in Fragile and conflict affected situations to that in Latin America(all income levels)?
Keep it short and to the point. 0.75. What is the ratio of the Rating (1=low 6=high) of 2005 in Fragile and conflict affected situations to that in Latin America(developing only)?
Your answer should be very brief. 0.78. What is the ratio of the Rating (1=low 6=high) in 2006 in Fragile and conflict affected situations to that in Latin America(developing only)?
Keep it short and to the point. 0.76. What is the ratio of the Rating (1=low 6=high) of 2007 in Fragile and conflict affected situations to that in Latin America(developing only)?
Keep it short and to the point. 0.76. What is the ratio of the Rating (1=low 6=high) in 2008 in Fragile and conflict affected situations to that in Latin America(developing only)?
Offer a terse response. 0.75. What is the ratio of the Rating (1=low 6=high) of 2005 in Heavily indebted poor countries to that in Latin America(all income levels)?
Your response must be concise. 0.85. What is the ratio of the Rating (1=low 6=high) in 2006 in Heavily indebted poor countries to that in Latin America(all income levels)?
Provide a short and direct response. 0.85. What is the ratio of the Rating (1=low 6=high) of 2007 in Heavily indebted poor countries to that in Latin America(all income levels)?
Provide a succinct answer. 0.85. What is the ratio of the Rating (1=low 6=high) of 2008 in Heavily indebted poor countries to that in Latin America(all income levels)?
Provide a succinct answer. 0.84. What is the ratio of the Rating (1=low 6=high) in 2005 in Heavily indebted poor countries to that in Latin America(developing only)?
Provide a short and direct response. 0.85. What is the ratio of the Rating (1=low 6=high) of 2006 in Heavily indebted poor countries to that in Latin America(developing only)?
Your answer should be very brief. 0.85. What is the ratio of the Rating (1=low 6=high) in 2007 in Heavily indebted poor countries to that in Latin America(developing only)?
Make the answer very short. 0.85. What is the ratio of the Rating (1=low 6=high) of 2008 in Heavily indebted poor countries to that in Latin America(developing only)?
Make the answer very short. 0.84. What is the ratio of the Rating (1=low 6=high) of 2006 in Latin America(all income levels) to that in Latin America(developing only)?
Your answer should be compact. 1. What is the difference between the highest and the lowest Rating (1=low 6=high) in 2005?
Offer a very short reply. 0.86. What is the difference between the highest and the lowest Rating (1=low 6=high) in 2006?
Provide a succinct answer. 0.92. What is the difference between the highest and the lowest Rating (1=low 6=high) of 2007?
Ensure brevity in your answer.  0.93. What is the difference between the highest and the lowest Rating (1=low 6=high) of 2008?
Give a very brief answer. 0.96. 